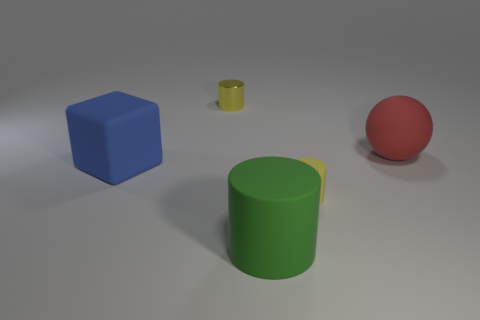Subtract all yellow cylinders. How many were subtracted if there are1yellow cylinders left? 1 Add 2 red shiny things. How many objects exist? 7 Subtract all balls. How many objects are left? 4 Add 2 metallic objects. How many metallic objects are left? 3 Add 5 tiny cylinders. How many tiny cylinders exist? 7 Subtract 1 blue cubes. How many objects are left? 4 Subtract all blue balls. Subtract all matte cylinders. How many objects are left? 3 